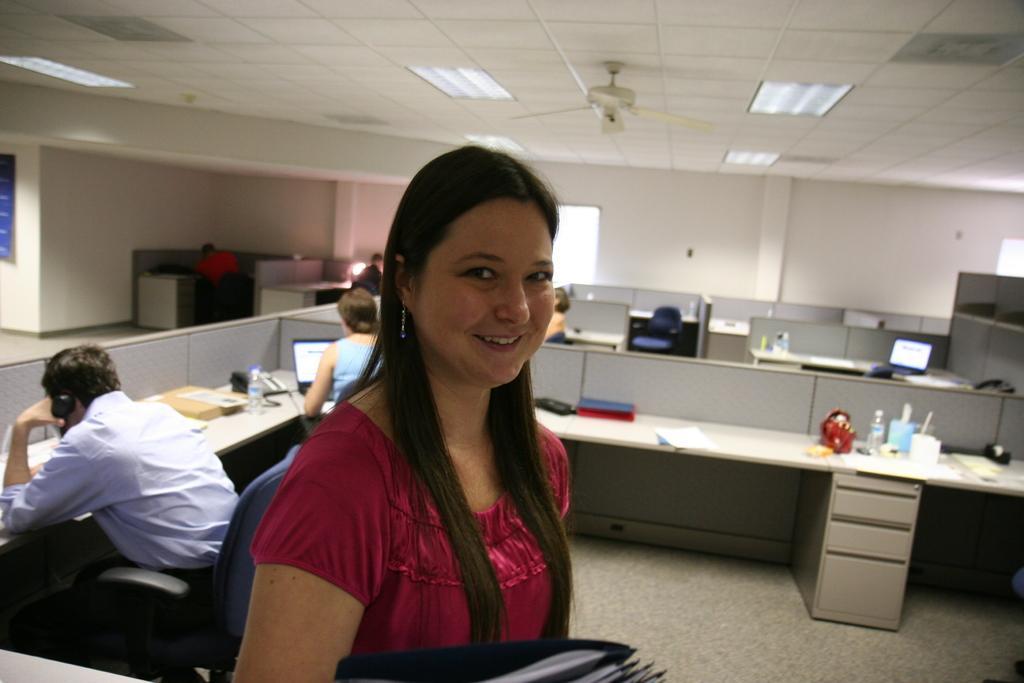Could you give a brief overview of what you see in this image? At the bottom we can see files and a woman is standing and smiling. In the background there are few persons sitting on the chairs at the table. On the table we can see computers,papers,water bottles and other objects. On the left there is a hoarding on the wall. In the background there are windows and we can see fan and lights on the ceiling. 